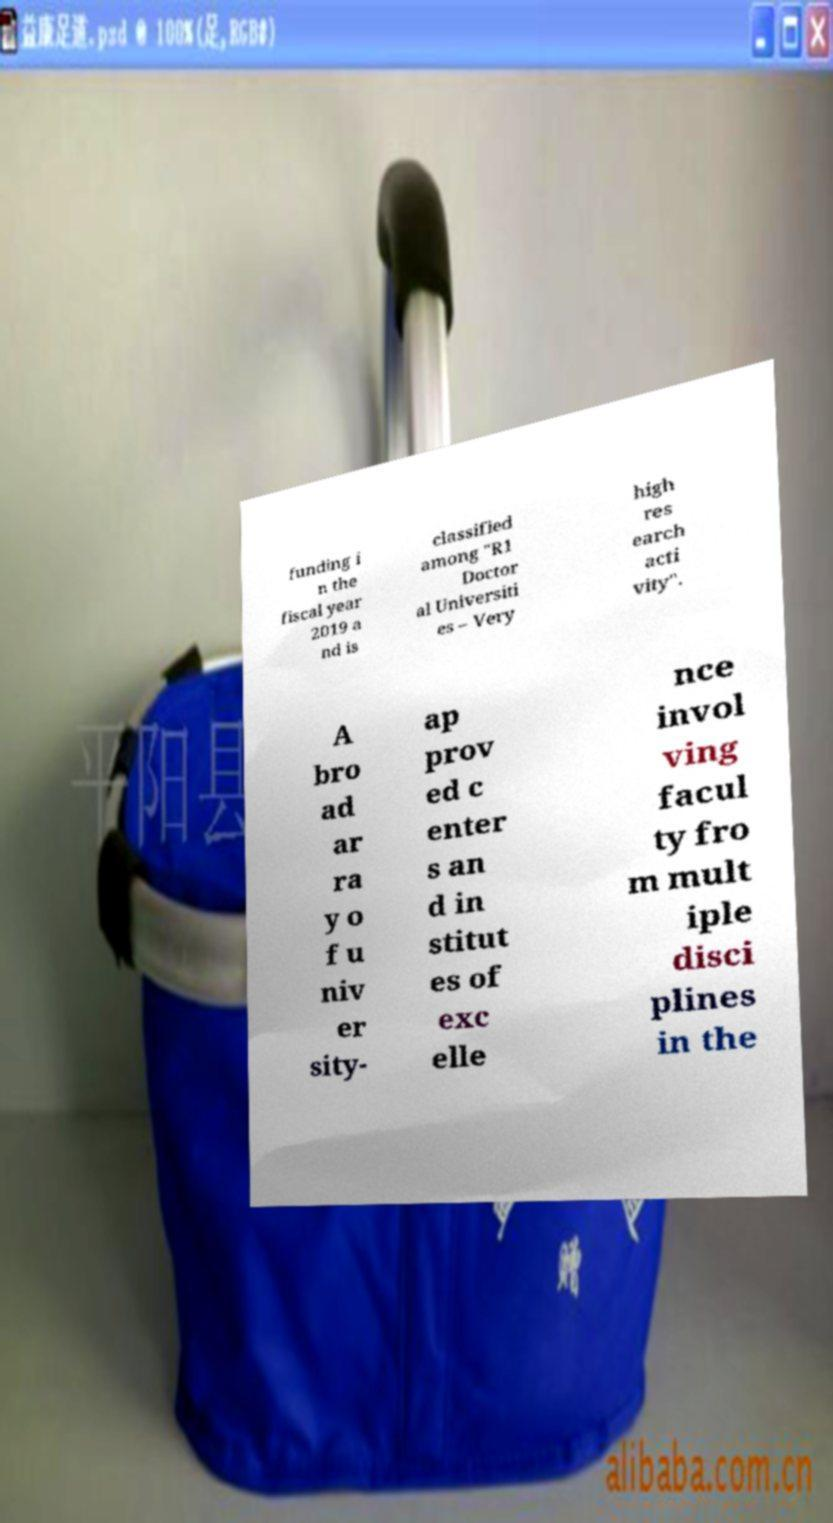Please identify and transcribe the text found in this image. funding i n the fiscal year 2019 a nd is classified among "R1 Doctor al Universiti es – Very high res earch acti vity". A bro ad ar ra y o f u niv er sity- ap prov ed c enter s an d in stitut es of exc elle nce invol ving facul ty fro m mult iple disci plines in the 